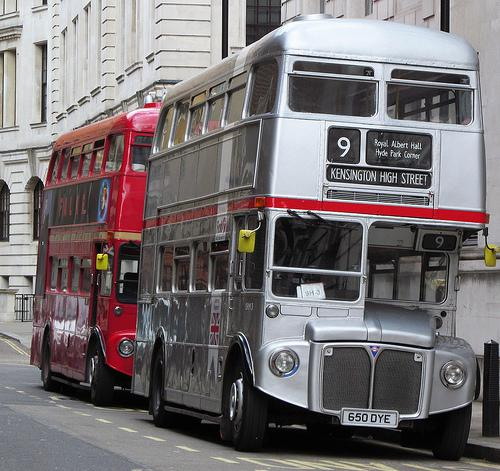Question: what is the license plate number of silver bus?
Choices:
A. 520 aie.
B. 777 man.
C. 650 DYE.
D. 852 saw.
Answer with the letter. Answer: C Question: how many buses are in the photo?
Choices:
A. 1.
B. 0.
C. 2.
D. 4.
Answer with the letter. Answer: C Question: where was the picture taken?
Choices:
A. In someone's yard.
B. In a gas station.
C. In the park.
D. In front of white building.
Answer with the letter. Answer: D Question: what color is the first bus?
Choices:
A. Red.
B. Black.
C. Silver.
D. Orange.
Answer with the letter. Answer: C Question: who took the picture?
Choices:
A. A photographer.
B. Her father.
C. A friendly stranger.
D. Her best friend.
Answer with the letter. Answer: A 